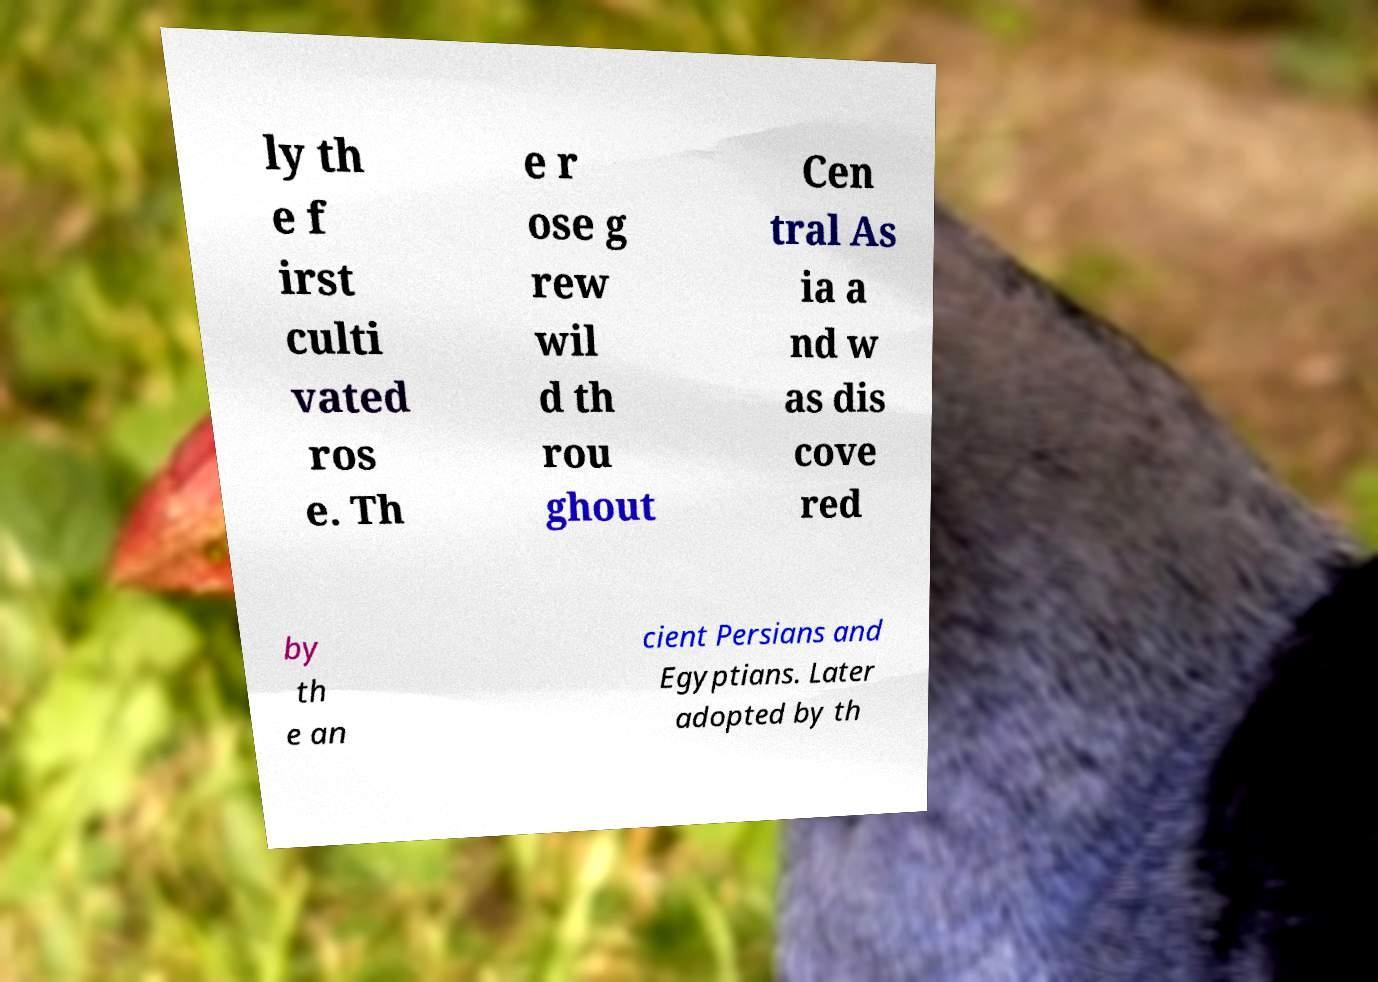Can you accurately transcribe the text from the provided image for me? ly th e f irst culti vated ros e. Th e r ose g rew wil d th rou ghout Cen tral As ia a nd w as dis cove red by th e an cient Persians and Egyptians. Later adopted by th 